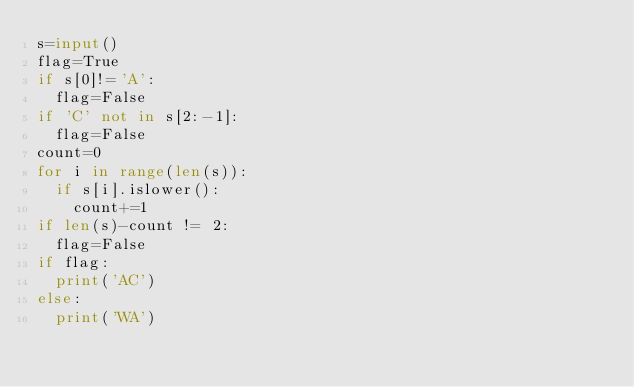Convert code to text. <code><loc_0><loc_0><loc_500><loc_500><_Python_>s=input()
flag=True
if s[0]!='A':
  flag=False
if 'C' not in s[2:-1]:
  flag=False
count=0
for i in range(len(s)):
  if s[i].islower():
    count+=1
if len(s)-count != 2:
  flag=False
if flag:
  print('AC')
else:
  print('WA')</code> 